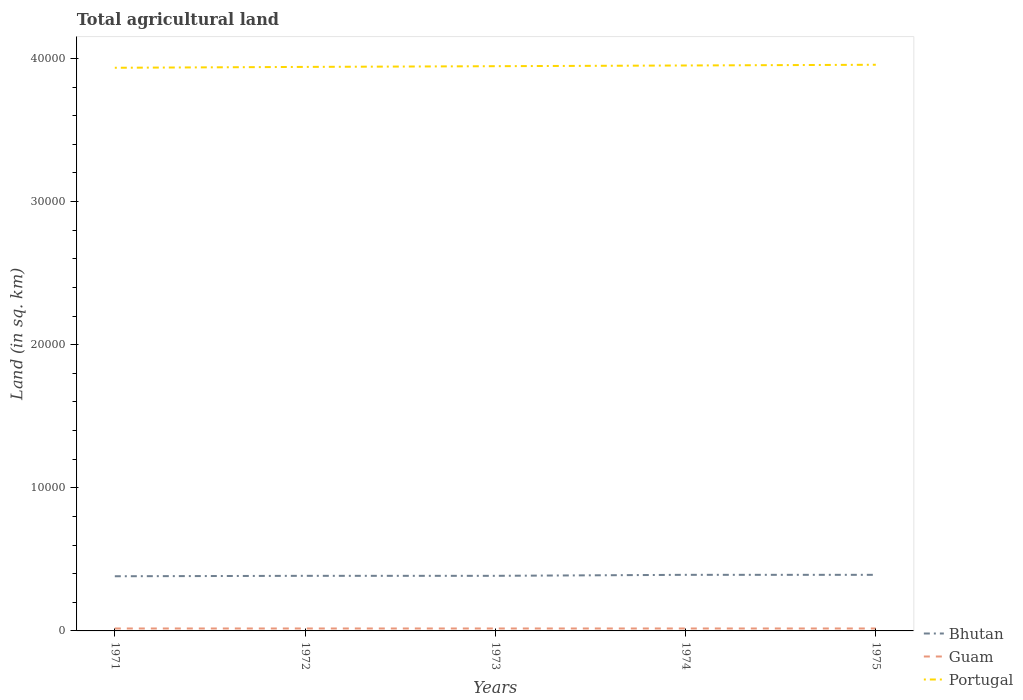How many different coloured lines are there?
Ensure brevity in your answer.  3. Does the line corresponding to Bhutan intersect with the line corresponding to Portugal?
Your response must be concise. No. Across all years, what is the maximum total agricultural land in Portugal?
Offer a very short reply. 3.94e+04. What is the total total agricultural land in Portugal in the graph?
Ensure brevity in your answer.  -50. What is the difference between the highest and the second highest total agricultural land in Bhutan?
Ensure brevity in your answer.  100. What is the difference between the highest and the lowest total agricultural land in Guam?
Your response must be concise. 0. Are the values on the major ticks of Y-axis written in scientific E-notation?
Give a very brief answer. No. Does the graph contain grids?
Keep it short and to the point. No. Where does the legend appear in the graph?
Provide a short and direct response. Bottom right. How many legend labels are there?
Give a very brief answer. 3. What is the title of the graph?
Keep it short and to the point. Total agricultural land. What is the label or title of the X-axis?
Make the answer very short. Years. What is the label or title of the Y-axis?
Give a very brief answer. Land (in sq. km). What is the Land (in sq. km) in Bhutan in 1971?
Provide a short and direct response. 3820. What is the Land (in sq. km) of Guam in 1971?
Keep it short and to the point. 170. What is the Land (in sq. km) in Portugal in 1971?
Ensure brevity in your answer.  3.94e+04. What is the Land (in sq. km) in Bhutan in 1972?
Your answer should be compact. 3850. What is the Land (in sq. km) in Guam in 1972?
Provide a short and direct response. 170. What is the Land (in sq. km) in Portugal in 1972?
Your answer should be compact. 3.94e+04. What is the Land (in sq. km) of Bhutan in 1973?
Make the answer very short. 3850. What is the Land (in sq. km) of Guam in 1973?
Make the answer very short. 170. What is the Land (in sq. km) in Portugal in 1973?
Keep it short and to the point. 3.95e+04. What is the Land (in sq. km) in Bhutan in 1974?
Make the answer very short. 3920. What is the Land (in sq. km) of Guam in 1974?
Your answer should be compact. 170. What is the Land (in sq. km) of Portugal in 1974?
Offer a very short reply. 3.95e+04. What is the Land (in sq. km) in Bhutan in 1975?
Make the answer very short. 3920. What is the Land (in sq. km) of Guam in 1975?
Your response must be concise. 170. What is the Land (in sq. km) in Portugal in 1975?
Ensure brevity in your answer.  3.96e+04. Across all years, what is the maximum Land (in sq. km) of Bhutan?
Your response must be concise. 3920. Across all years, what is the maximum Land (in sq. km) in Guam?
Your answer should be very brief. 170. Across all years, what is the maximum Land (in sq. km) in Portugal?
Give a very brief answer. 3.96e+04. Across all years, what is the minimum Land (in sq. km) in Bhutan?
Offer a very short reply. 3820. Across all years, what is the minimum Land (in sq. km) in Guam?
Make the answer very short. 170. Across all years, what is the minimum Land (in sq. km) of Portugal?
Your answer should be compact. 3.94e+04. What is the total Land (in sq. km) of Bhutan in the graph?
Provide a succinct answer. 1.94e+04. What is the total Land (in sq. km) of Guam in the graph?
Provide a short and direct response. 850. What is the total Land (in sq. km) in Portugal in the graph?
Your response must be concise. 1.97e+05. What is the difference between the Land (in sq. km) of Bhutan in 1971 and that in 1972?
Your response must be concise. -30. What is the difference between the Land (in sq. km) of Guam in 1971 and that in 1972?
Your answer should be compact. 0. What is the difference between the Land (in sq. km) in Portugal in 1971 and that in 1972?
Offer a very short reply. -60. What is the difference between the Land (in sq. km) in Bhutan in 1971 and that in 1973?
Offer a terse response. -30. What is the difference between the Land (in sq. km) in Guam in 1971 and that in 1973?
Offer a terse response. 0. What is the difference between the Land (in sq. km) in Portugal in 1971 and that in 1973?
Your answer should be very brief. -110. What is the difference between the Land (in sq. km) of Bhutan in 1971 and that in 1974?
Keep it short and to the point. -100. What is the difference between the Land (in sq. km) in Portugal in 1971 and that in 1974?
Your answer should be compact. -160. What is the difference between the Land (in sq. km) of Bhutan in 1971 and that in 1975?
Offer a terse response. -100. What is the difference between the Land (in sq. km) of Portugal in 1971 and that in 1975?
Provide a short and direct response. -210. What is the difference between the Land (in sq. km) of Guam in 1972 and that in 1973?
Offer a terse response. 0. What is the difference between the Land (in sq. km) of Portugal in 1972 and that in 1973?
Give a very brief answer. -50. What is the difference between the Land (in sq. km) in Bhutan in 1972 and that in 1974?
Ensure brevity in your answer.  -70. What is the difference between the Land (in sq. km) of Guam in 1972 and that in 1974?
Make the answer very short. 0. What is the difference between the Land (in sq. km) of Portugal in 1972 and that in 1974?
Provide a succinct answer. -100. What is the difference between the Land (in sq. km) of Bhutan in 1972 and that in 1975?
Your response must be concise. -70. What is the difference between the Land (in sq. km) of Guam in 1972 and that in 1975?
Keep it short and to the point. 0. What is the difference between the Land (in sq. km) in Portugal in 1972 and that in 1975?
Give a very brief answer. -150. What is the difference between the Land (in sq. km) of Bhutan in 1973 and that in 1974?
Provide a succinct answer. -70. What is the difference between the Land (in sq. km) in Portugal in 1973 and that in 1974?
Your response must be concise. -50. What is the difference between the Land (in sq. km) of Bhutan in 1973 and that in 1975?
Provide a short and direct response. -70. What is the difference between the Land (in sq. km) in Portugal in 1973 and that in 1975?
Your answer should be compact. -100. What is the difference between the Land (in sq. km) of Bhutan in 1974 and that in 1975?
Give a very brief answer. 0. What is the difference between the Land (in sq. km) of Portugal in 1974 and that in 1975?
Provide a short and direct response. -50. What is the difference between the Land (in sq. km) in Bhutan in 1971 and the Land (in sq. km) in Guam in 1972?
Make the answer very short. 3650. What is the difference between the Land (in sq. km) in Bhutan in 1971 and the Land (in sq. km) in Portugal in 1972?
Your answer should be very brief. -3.56e+04. What is the difference between the Land (in sq. km) in Guam in 1971 and the Land (in sq. km) in Portugal in 1972?
Ensure brevity in your answer.  -3.92e+04. What is the difference between the Land (in sq. km) of Bhutan in 1971 and the Land (in sq. km) of Guam in 1973?
Your answer should be very brief. 3650. What is the difference between the Land (in sq. km) of Bhutan in 1971 and the Land (in sq. km) of Portugal in 1973?
Provide a succinct answer. -3.56e+04. What is the difference between the Land (in sq. km) in Guam in 1971 and the Land (in sq. km) in Portugal in 1973?
Your answer should be very brief. -3.93e+04. What is the difference between the Land (in sq. km) in Bhutan in 1971 and the Land (in sq. km) in Guam in 1974?
Ensure brevity in your answer.  3650. What is the difference between the Land (in sq. km) in Bhutan in 1971 and the Land (in sq. km) in Portugal in 1974?
Give a very brief answer. -3.57e+04. What is the difference between the Land (in sq. km) in Guam in 1971 and the Land (in sq. km) in Portugal in 1974?
Ensure brevity in your answer.  -3.93e+04. What is the difference between the Land (in sq. km) of Bhutan in 1971 and the Land (in sq. km) of Guam in 1975?
Your answer should be very brief. 3650. What is the difference between the Land (in sq. km) of Bhutan in 1971 and the Land (in sq. km) of Portugal in 1975?
Your answer should be very brief. -3.57e+04. What is the difference between the Land (in sq. km) in Guam in 1971 and the Land (in sq. km) in Portugal in 1975?
Ensure brevity in your answer.  -3.94e+04. What is the difference between the Land (in sq. km) in Bhutan in 1972 and the Land (in sq. km) in Guam in 1973?
Ensure brevity in your answer.  3680. What is the difference between the Land (in sq. km) of Bhutan in 1972 and the Land (in sq. km) of Portugal in 1973?
Offer a terse response. -3.56e+04. What is the difference between the Land (in sq. km) in Guam in 1972 and the Land (in sq. km) in Portugal in 1973?
Offer a very short reply. -3.93e+04. What is the difference between the Land (in sq. km) in Bhutan in 1972 and the Land (in sq. km) in Guam in 1974?
Make the answer very short. 3680. What is the difference between the Land (in sq. km) of Bhutan in 1972 and the Land (in sq. km) of Portugal in 1974?
Ensure brevity in your answer.  -3.57e+04. What is the difference between the Land (in sq. km) in Guam in 1972 and the Land (in sq. km) in Portugal in 1974?
Your answer should be compact. -3.93e+04. What is the difference between the Land (in sq. km) in Bhutan in 1972 and the Land (in sq. km) in Guam in 1975?
Offer a very short reply. 3680. What is the difference between the Land (in sq. km) in Bhutan in 1972 and the Land (in sq. km) in Portugal in 1975?
Your response must be concise. -3.57e+04. What is the difference between the Land (in sq. km) in Guam in 1972 and the Land (in sq. km) in Portugal in 1975?
Your answer should be compact. -3.94e+04. What is the difference between the Land (in sq. km) in Bhutan in 1973 and the Land (in sq. km) in Guam in 1974?
Provide a short and direct response. 3680. What is the difference between the Land (in sq. km) in Bhutan in 1973 and the Land (in sq. km) in Portugal in 1974?
Offer a very short reply. -3.57e+04. What is the difference between the Land (in sq. km) in Guam in 1973 and the Land (in sq. km) in Portugal in 1974?
Your answer should be compact. -3.93e+04. What is the difference between the Land (in sq. km) in Bhutan in 1973 and the Land (in sq. km) in Guam in 1975?
Offer a very short reply. 3680. What is the difference between the Land (in sq. km) in Bhutan in 1973 and the Land (in sq. km) in Portugal in 1975?
Make the answer very short. -3.57e+04. What is the difference between the Land (in sq. km) of Guam in 1973 and the Land (in sq. km) of Portugal in 1975?
Keep it short and to the point. -3.94e+04. What is the difference between the Land (in sq. km) of Bhutan in 1974 and the Land (in sq. km) of Guam in 1975?
Keep it short and to the point. 3750. What is the difference between the Land (in sq. km) in Bhutan in 1974 and the Land (in sq. km) in Portugal in 1975?
Provide a short and direct response. -3.56e+04. What is the difference between the Land (in sq. km) of Guam in 1974 and the Land (in sq. km) of Portugal in 1975?
Your answer should be compact. -3.94e+04. What is the average Land (in sq. km) of Bhutan per year?
Provide a succinct answer. 3872. What is the average Land (in sq. km) in Guam per year?
Offer a very short reply. 170. What is the average Land (in sq. km) of Portugal per year?
Your response must be concise. 3.95e+04. In the year 1971, what is the difference between the Land (in sq. km) in Bhutan and Land (in sq. km) in Guam?
Your answer should be very brief. 3650. In the year 1971, what is the difference between the Land (in sq. km) of Bhutan and Land (in sq. km) of Portugal?
Provide a short and direct response. -3.55e+04. In the year 1971, what is the difference between the Land (in sq. km) of Guam and Land (in sq. km) of Portugal?
Make the answer very short. -3.92e+04. In the year 1972, what is the difference between the Land (in sq. km) of Bhutan and Land (in sq. km) of Guam?
Provide a succinct answer. 3680. In the year 1972, what is the difference between the Land (in sq. km) in Bhutan and Land (in sq. km) in Portugal?
Your answer should be compact. -3.56e+04. In the year 1972, what is the difference between the Land (in sq. km) of Guam and Land (in sq. km) of Portugal?
Your response must be concise. -3.92e+04. In the year 1973, what is the difference between the Land (in sq. km) of Bhutan and Land (in sq. km) of Guam?
Ensure brevity in your answer.  3680. In the year 1973, what is the difference between the Land (in sq. km) in Bhutan and Land (in sq. km) in Portugal?
Your answer should be compact. -3.56e+04. In the year 1973, what is the difference between the Land (in sq. km) in Guam and Land (in sq. km) in Portugal?
Give a very brief answer. -3.93e+04. In the year 1974, what is the difference between the Land (in sq. km) of Bhutan and Land (in sq. km) of Guam?
Your response must be concise. 3750. In the year 1974, what is the difference between the Land (in sq. km) in Bhutan and Land (in sq. km) in Portugal?
Provide a succinct answer. -3.56e+04. In the year 1974, what is the difference between the Land (in sq. km) in Guam and Land (in sq. km) in Portugal?
Give a very brief answer. -3.93e+04. In the year 1975, what is the difference between the Land (in sq. km) in Bhutan and Land (in sq. km) in Guam?
Your answer should be compact. 3750. In the year 1975, what is the difference between the Land (in sq. km) in Bhutan and Land (in sq. km) in Portugal?
Ensure brevity in your answer.  -3.56e+04. In the year 1975, what is the difference between the Land (in sq. km) of Guam and Land (in sq. km) of Portugal?
Your answer should be very brief. -3.94e+04. What is the ratio of the Land (in sq. km) of Guam in 1971 to that in 1972?
Give a very brief answer. 1. What is the ratio of the Land (in sq. km) in Guam in 1971 to that in 1973?
Ensure brevity in your answer.  1. What is the ratio of the Land (in sq. km) in Portugal in 1971 to that in 1973?
Your answer should be compact. 1. What is the ratio of the Land (in sq. km) in Bhutan in 1971 to that in 1974?
Provide a succinct answer. 0.97. What is the ratio of the Land (in sq. km) of Guam in 1971 to that in 1974?
Keep it short and to the point. 1. What is the ratio of the Land (in sq. km) in Bhutan in 1971 to that in 1975?
Your answer should be compact. 0.97. What is the ratio of the Land (in sq. km) of Portugal in 1971 to that in 1975?
Offer a terse response. 0.99. What is the ratio of the Land (in sq. km) of Bhutan in 1972 to that in 1973?
Offer a terse response. 1. What is the ratio of the Land (in sq. km) in Guam in 1972 to that in 1973?
Your response must be concise. 1. What is the ratio of the Land (in sq. km) in Portugal in 1972 to that in 1973?
Keep it short and to the point. 1. What is the ratio of the Land (in sq. km) of Bhutan in 1972 to that in 1974?
Your answer should be very brief. 0.98. What is the ratio of the Land (in sq. km) of Portugal in 1972 to that in 1974?
Give a very brief answer. 1. What is the ratio of the Land (in sq. km) in Bhutan in 1972 to that in 1975?
Your response must be concise. 0.98. What is the ratio of the Land (in sq. km) of Guam in 1972 to that in 1975?
Give a very brief answer. 1. What is the ratio of the Land (in sq. km) of Portugal in 1972 to that in 1975?
Offer a very short reply. 1. What is the ratio of the Land (in sq. km) in Bhutan in 1973 to that in 1974?
Provide a succinct answer. 0.98. What is the ratio of the Land (in sq. km) of Bhutan in 1973 to that in 1975?
Offer a very short reply. 0.98. What is the ratio of the Land (in sq. km) of Guam in 1973 to that in 1975?
Ensure brevity in your answer.  1. What is the ratio of the Land (in sq. km) of Portugal in 1973 to that in 1975?
Provide a short and direct response. 1. What is the ratio of the Land (in sq. km) in Bhutan in 1974 to that in 1975?
Provide a short and direct response. 1. What is the ratio of the Land (in sq. km) in Guam in 1974 to that in 1975?
Give a very brief answer. 1. What is the difference between the highest and the second highest Land (in sq. km) of Guam?
Make the answer very short. 0. What is the difference between the highest and the lowest Land (in sq. km) in Guam?
Keep it short and to the point. 0. What is the difference between the highest and the lowest Land (in sq. km) of Portugal?
Your answer should be compact. 210. 